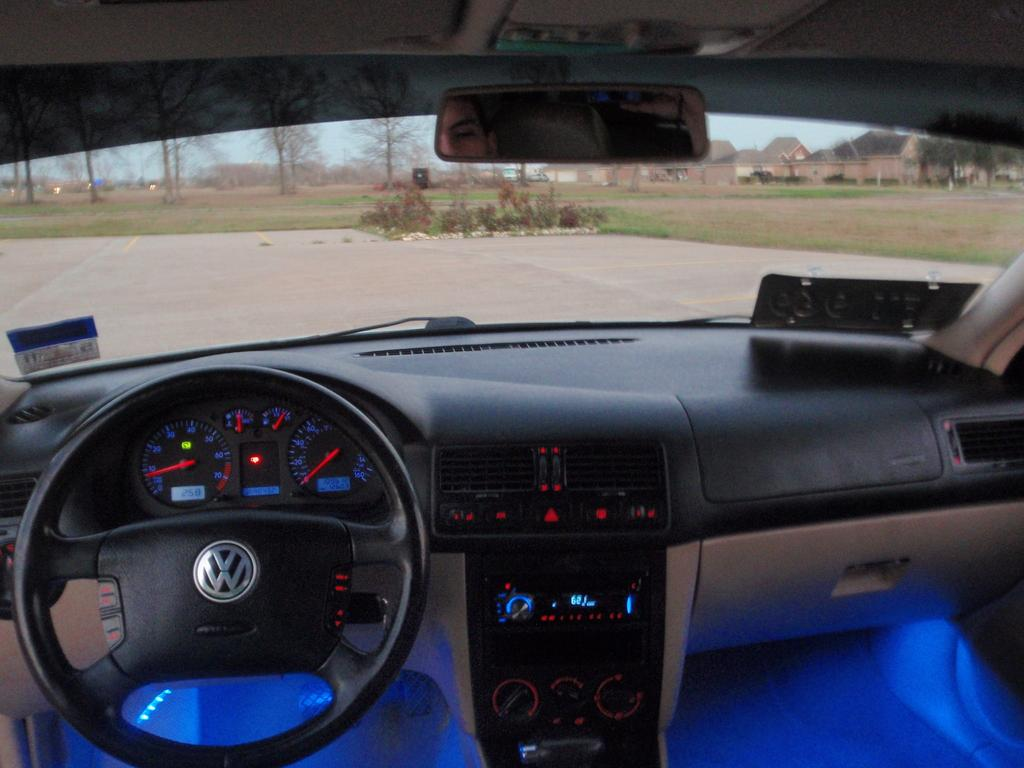What is the perspective of the image? The image is taken from inside a car. What can be seen in the car? There is a steering wheel visible in the image. What is visible outside the car? There are trees visible in the image. What type of lamp is hanging from the tree in the image? There is no lamp hanging from the tree in the image; only trees are visible. 